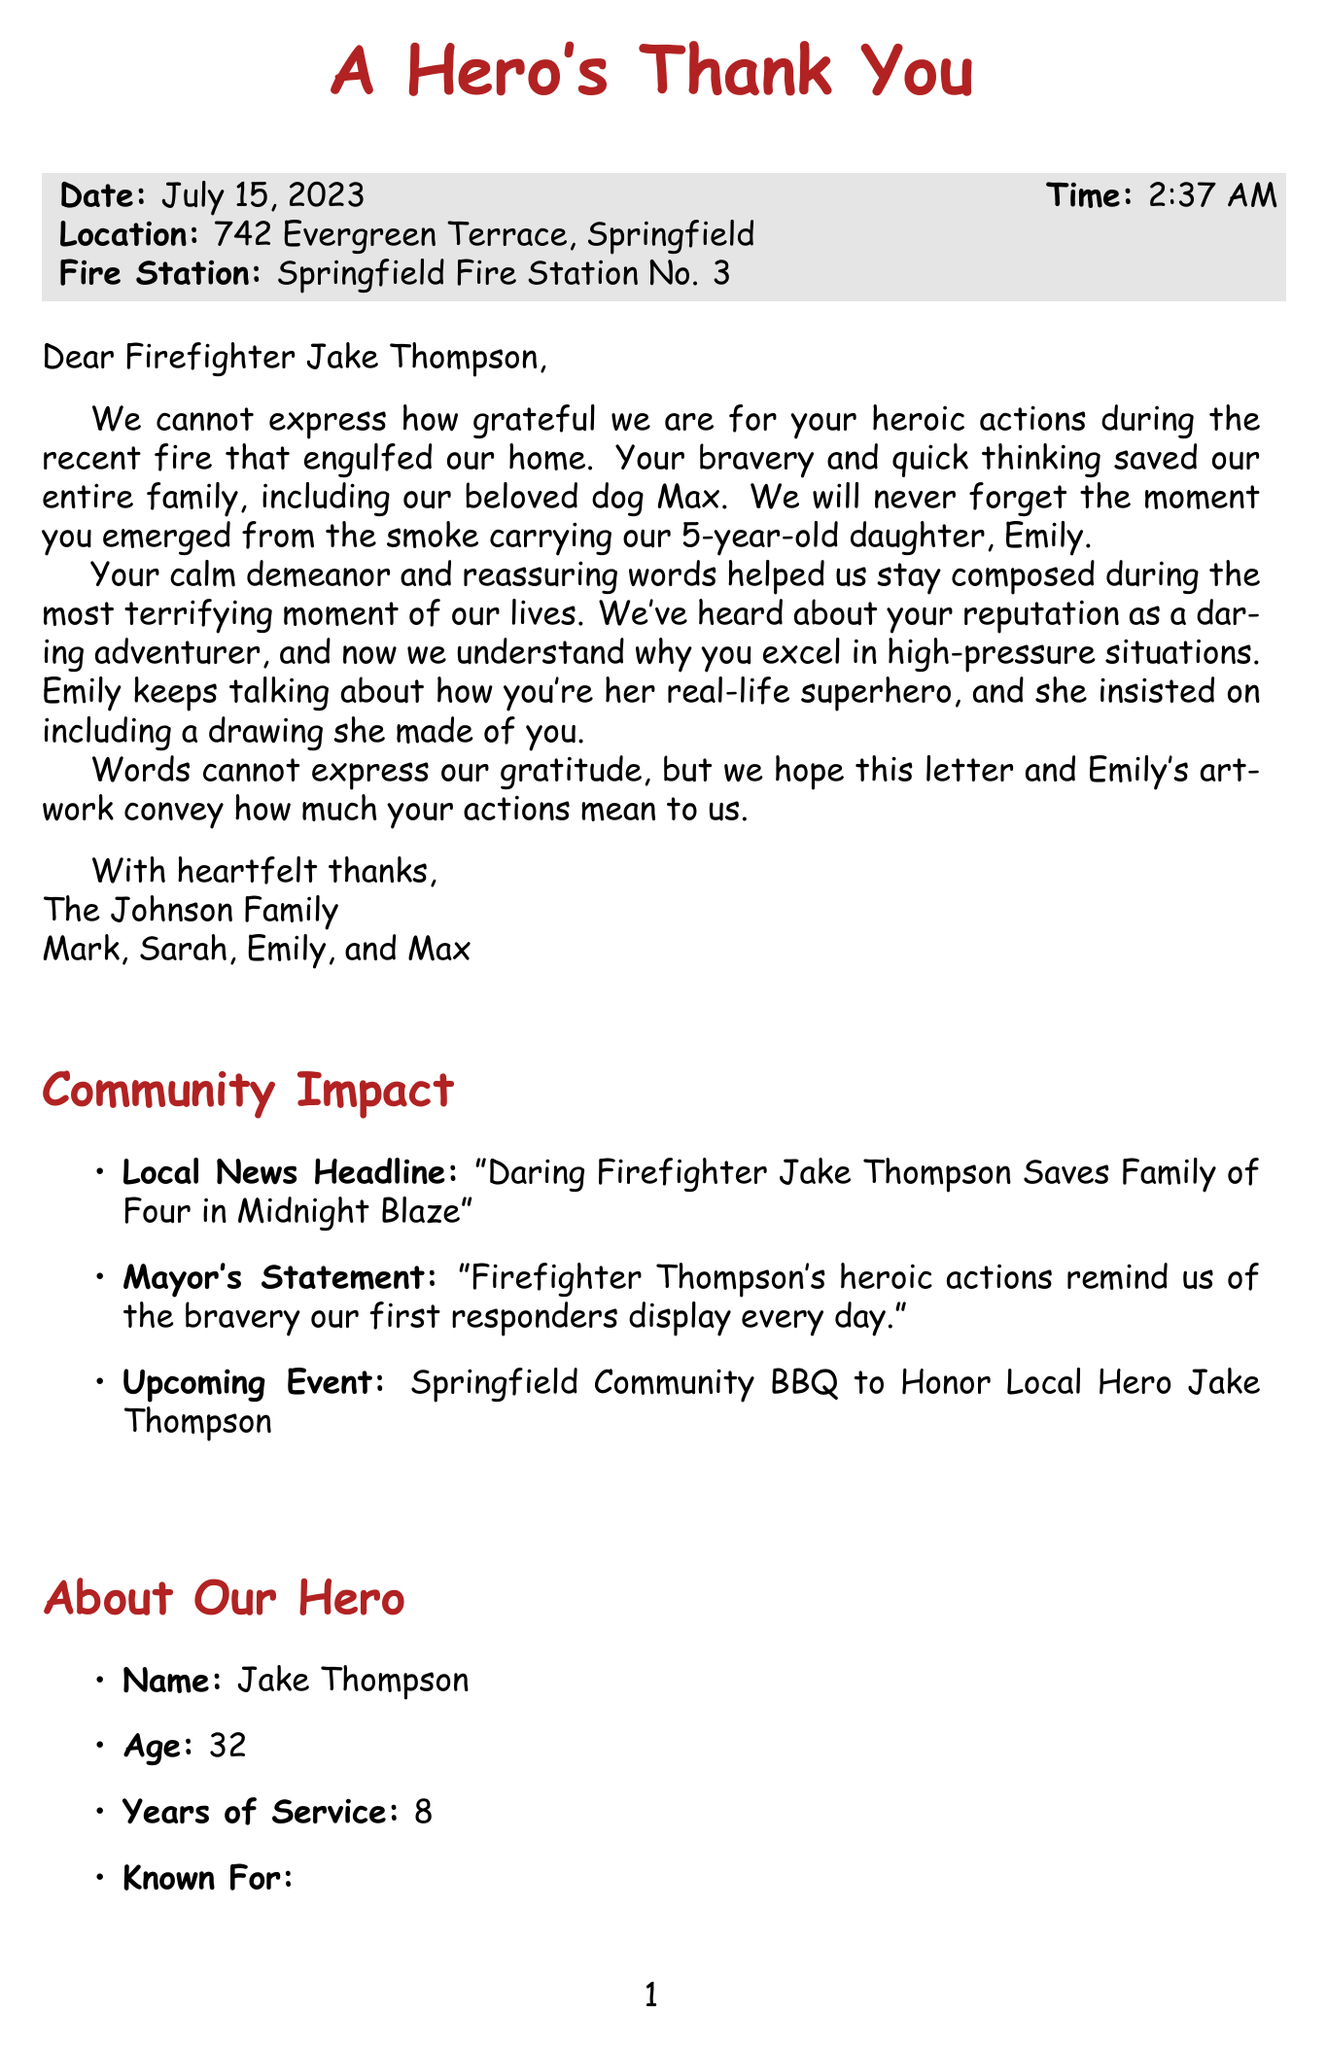What is the name of the firefighter? The name of the firefighter is provided in the salutation of the letter.
Answer: Jake Thompson What date did the rescue occur? The date is mentioned in the section that provides specifics about the incident.
Answer: July 15, 2023 Who is the child that was rescued? The body of the letter mentions the age and name of the child who was rescued.
Answer: Emily Johnson What is the pet's name? The pet is mentioned in the context of the family's gratitude, specifically highlighting their beloved dog.
Answer: Max What is the community event honoring Jake Thompson? The community impact section describes an upcoming event to honor the firefighter's heroic actions.
Answer: Springfield Community BBQ How old is Jake Thompson? The age of the firefighter is mentioned in the "About Our Hero" section.
Answer: 32 What drawing did Emily include? The letter mentions Emily's artwork depicting the firefighter in a certain way.
Answer: A crayon drawing depicting Firefighter Jake in a red cape What is the caption of the child's drawing? The drawing description includes a specific caption that reflects how the child views the firefighter.
Answer: My Hero Firefighter Jake! What did the Mayor say about Jake Thompson? The mayor's statement provided in the community impact section expresses a sentiment around the firefighter's actions.
Answer: Firefighter Thompson's heroic actions remind us of the bravery our first responders display every day Why did the family include a drawing from Emily? The letter illustrates Emily's perspective of the firefighter as her hero, prompting the inclusion of her drawing.
Answer: She insisted on including a drawing she made of you 